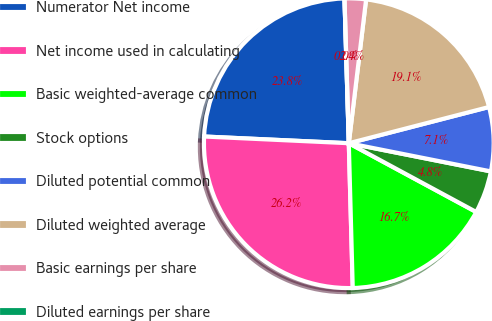Convert chart. <chart><loc_0><loc_0><loc_500><loc_500><pie_chart><fcel>Numerator Net income<fcel>Net income used in calculating<fcel>Basic weighted-average common<fcel>Stock options<fcel>Diluted potential common<fcel>Diluted weighted average<fcel>Basic earnings per share<fcel>Diluted earnings per share<nl><fcel>23.79%<fcel>26.17%<fcel>16.69%<fcel>4.76%<fcel>7.14%<fcel>19.07%<fcel>2.38%<fcel>0.0%<nl></chart> 